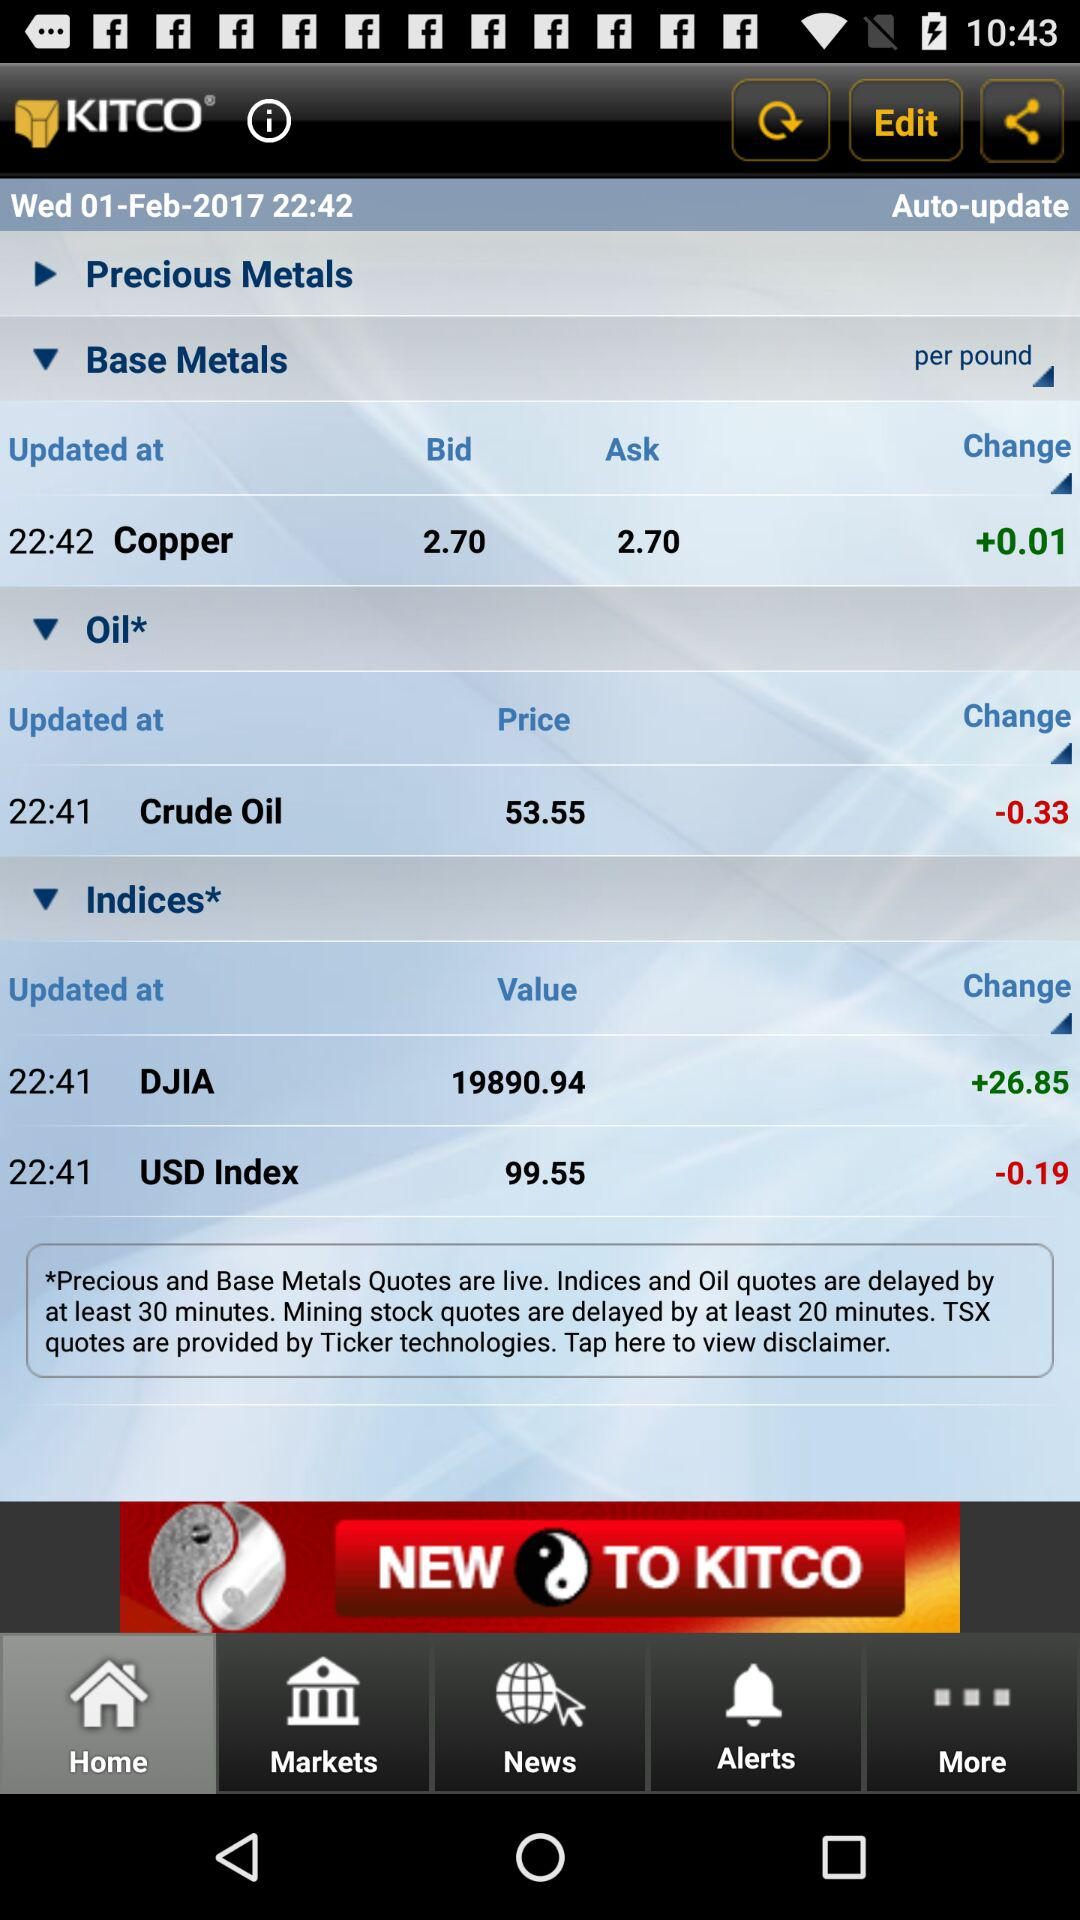What's the value of DJIA? The value of DJIA is 19890.94. 